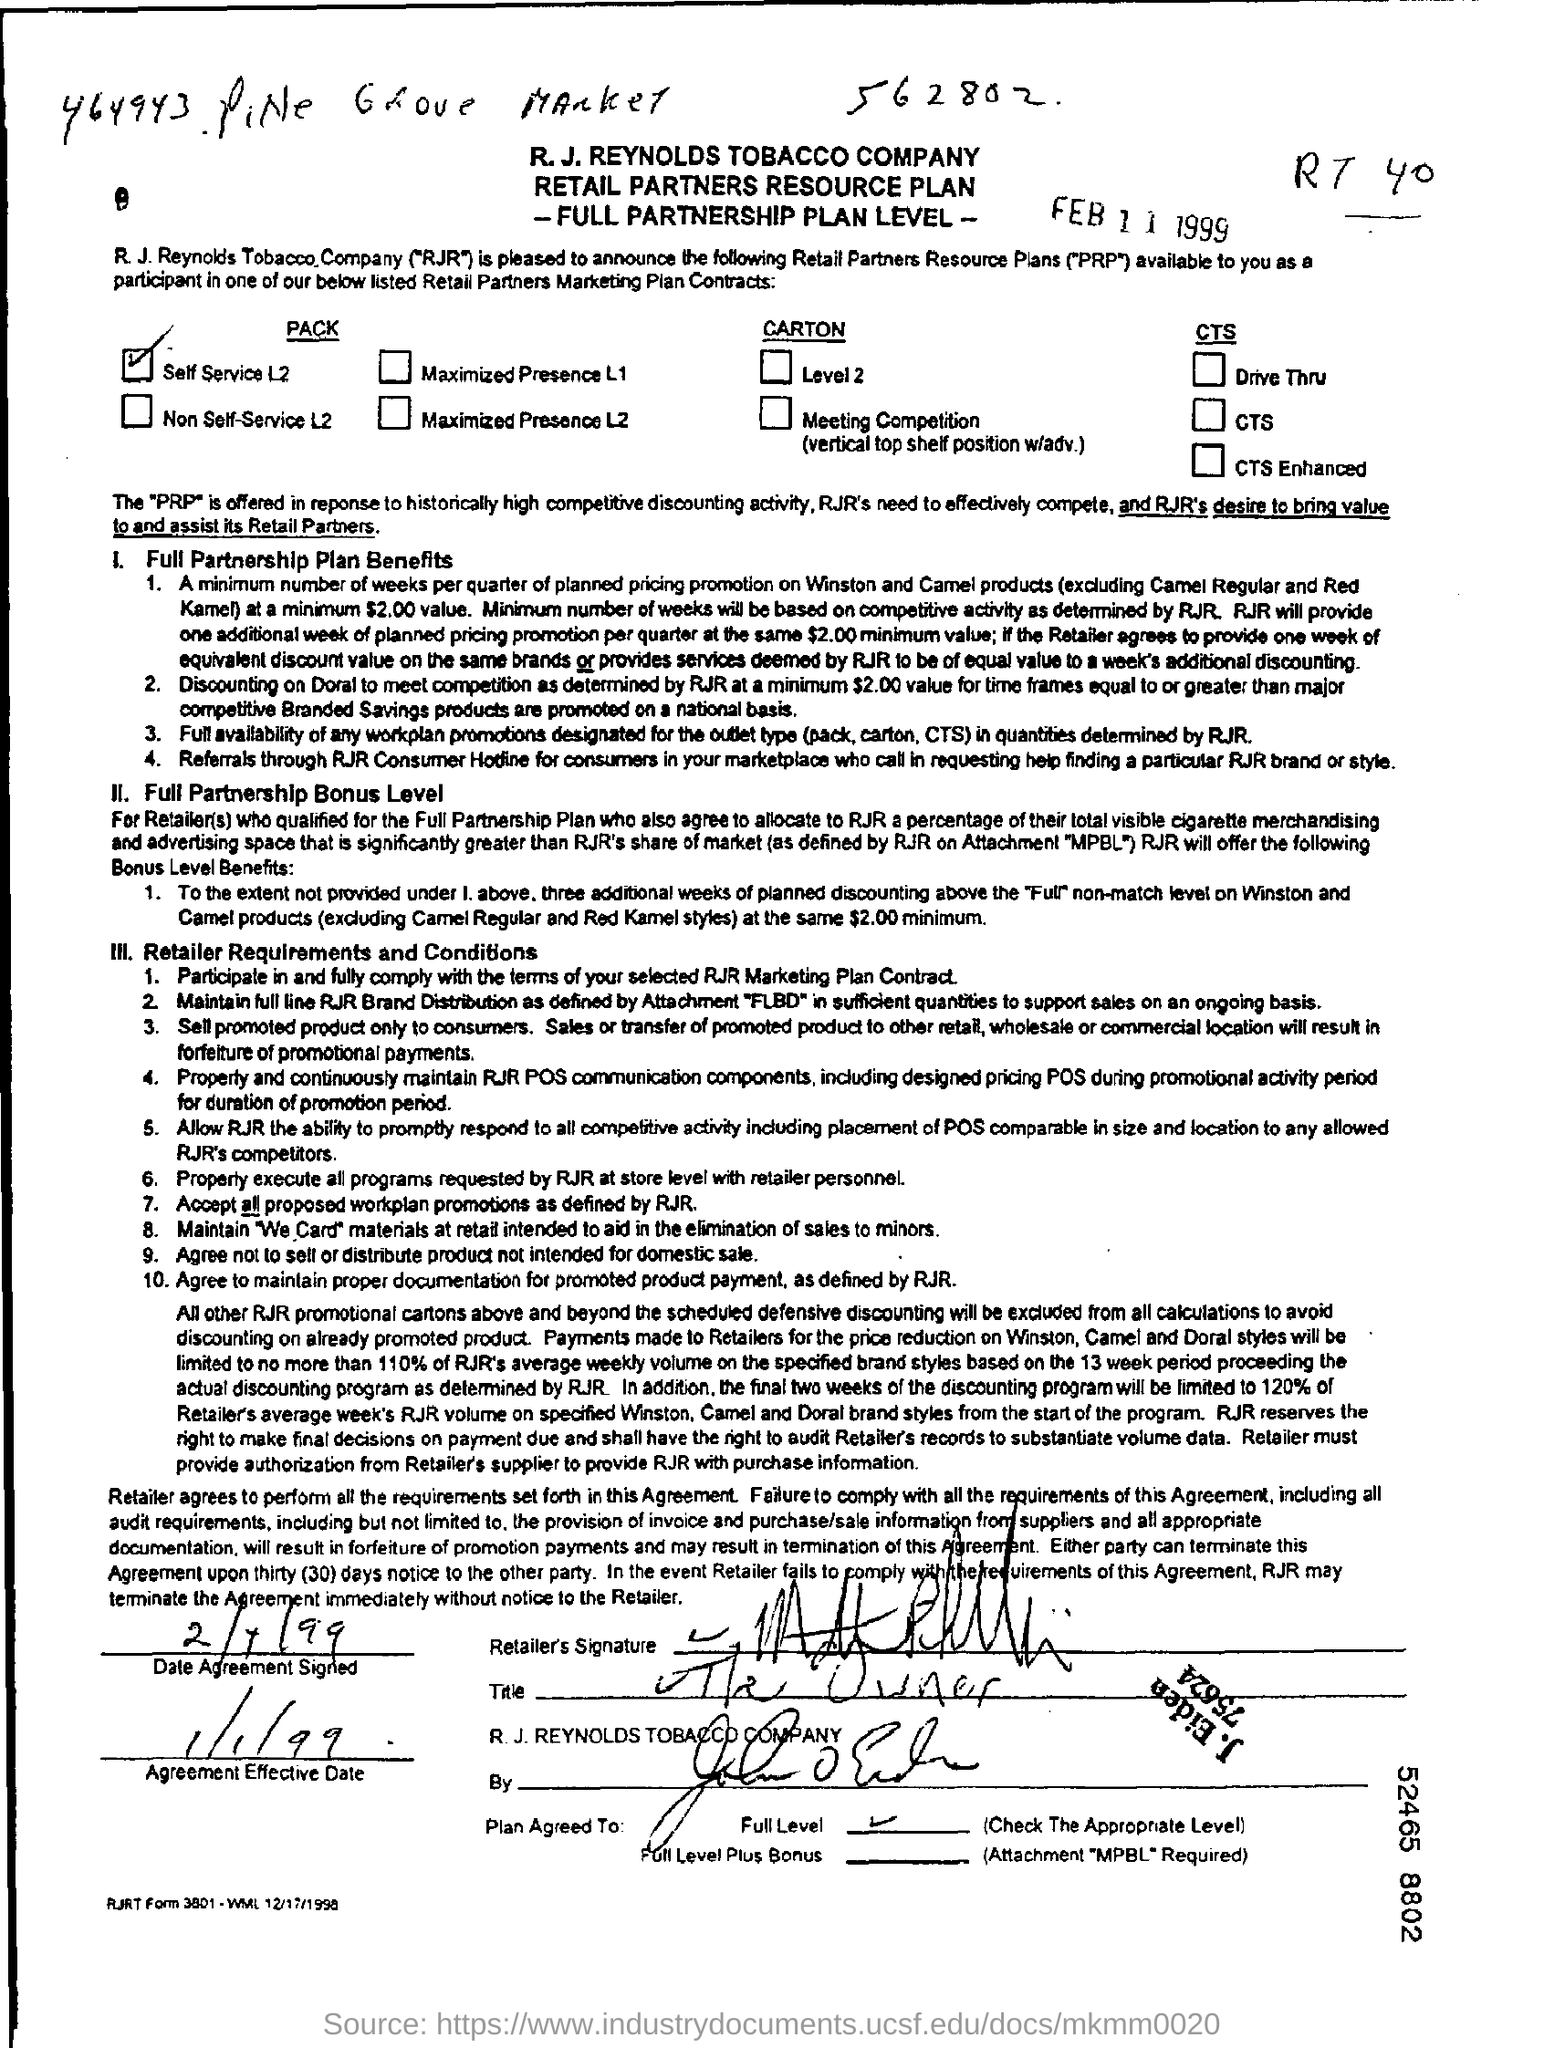Highlight a few significant elements in this photo. The date printed is February 11, 1999. The agreement is effective as of January 1, 1999. 